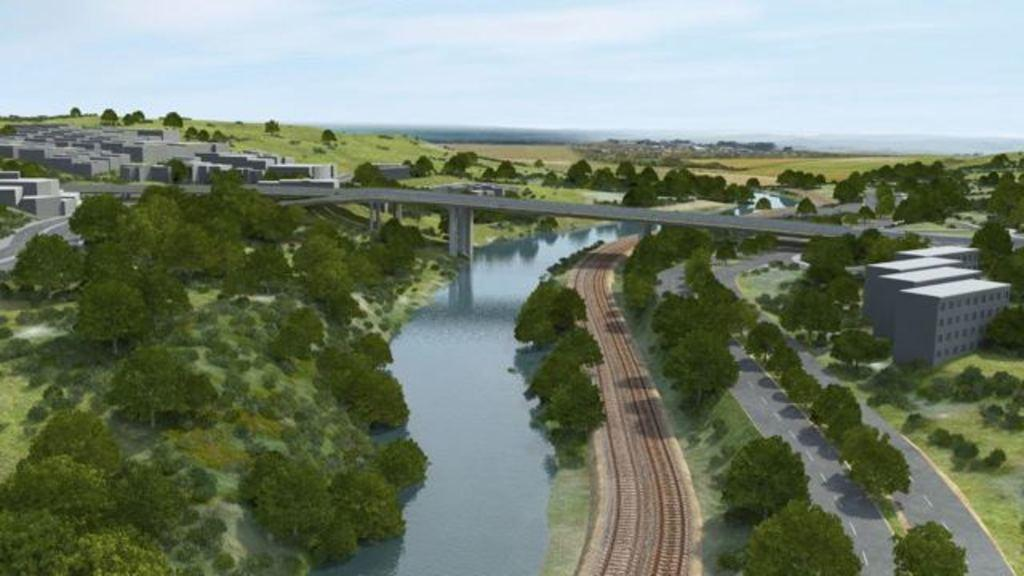What type of illustration is in the image? The image contains a cartoon. What natural elements can be seen in the image? There are trees and water in the image. What man-made structure is present in the image? There is a bridge in the image. What type of buildings are visible in the image? There are buildings in the image. What transportation-related feature is present in the image? Railway tracks are present in the image. What part of the natural environment is visible in the image? The sky is visible in the image. What type of lettuce is being used as a hat by the cartoon character in the image? There is no lettuce or cartoon character wearing a lettuce hat present in the image. 